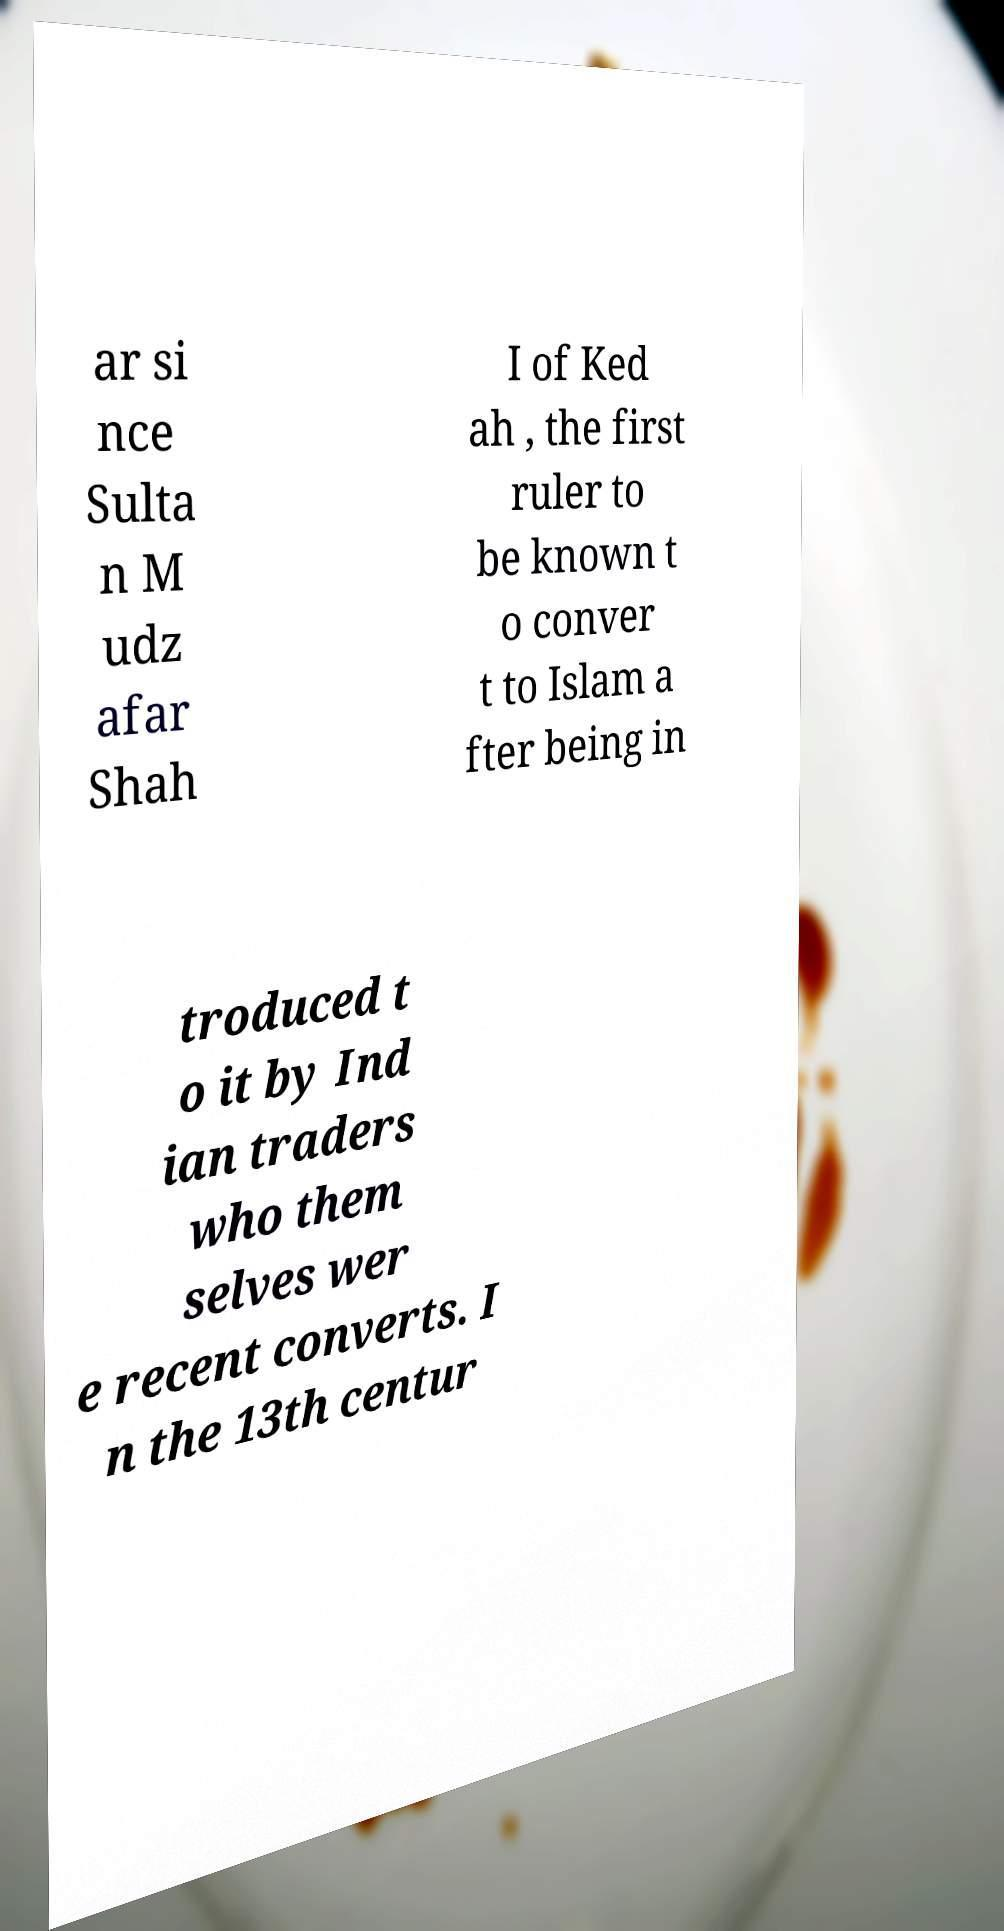Could you extract and type out the text from this image? ar si nce Sulta n M udz afar Shah I of Ked ah , the first ruler to be known t o conver t to Islam a fter being in troduced t o it by Ind ian traders who them selves wer e recent converts. I n the 13th centur 